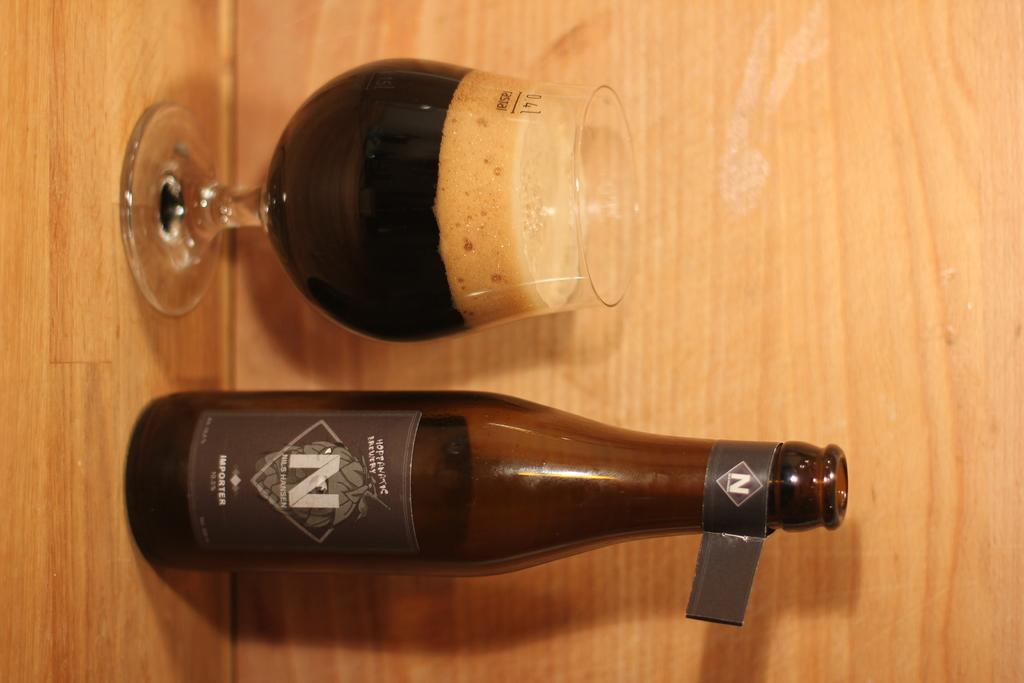<image>
Write a terse but informative summary of the picture. N Importer beer with mostly full snifter next to it with foam at the top. 